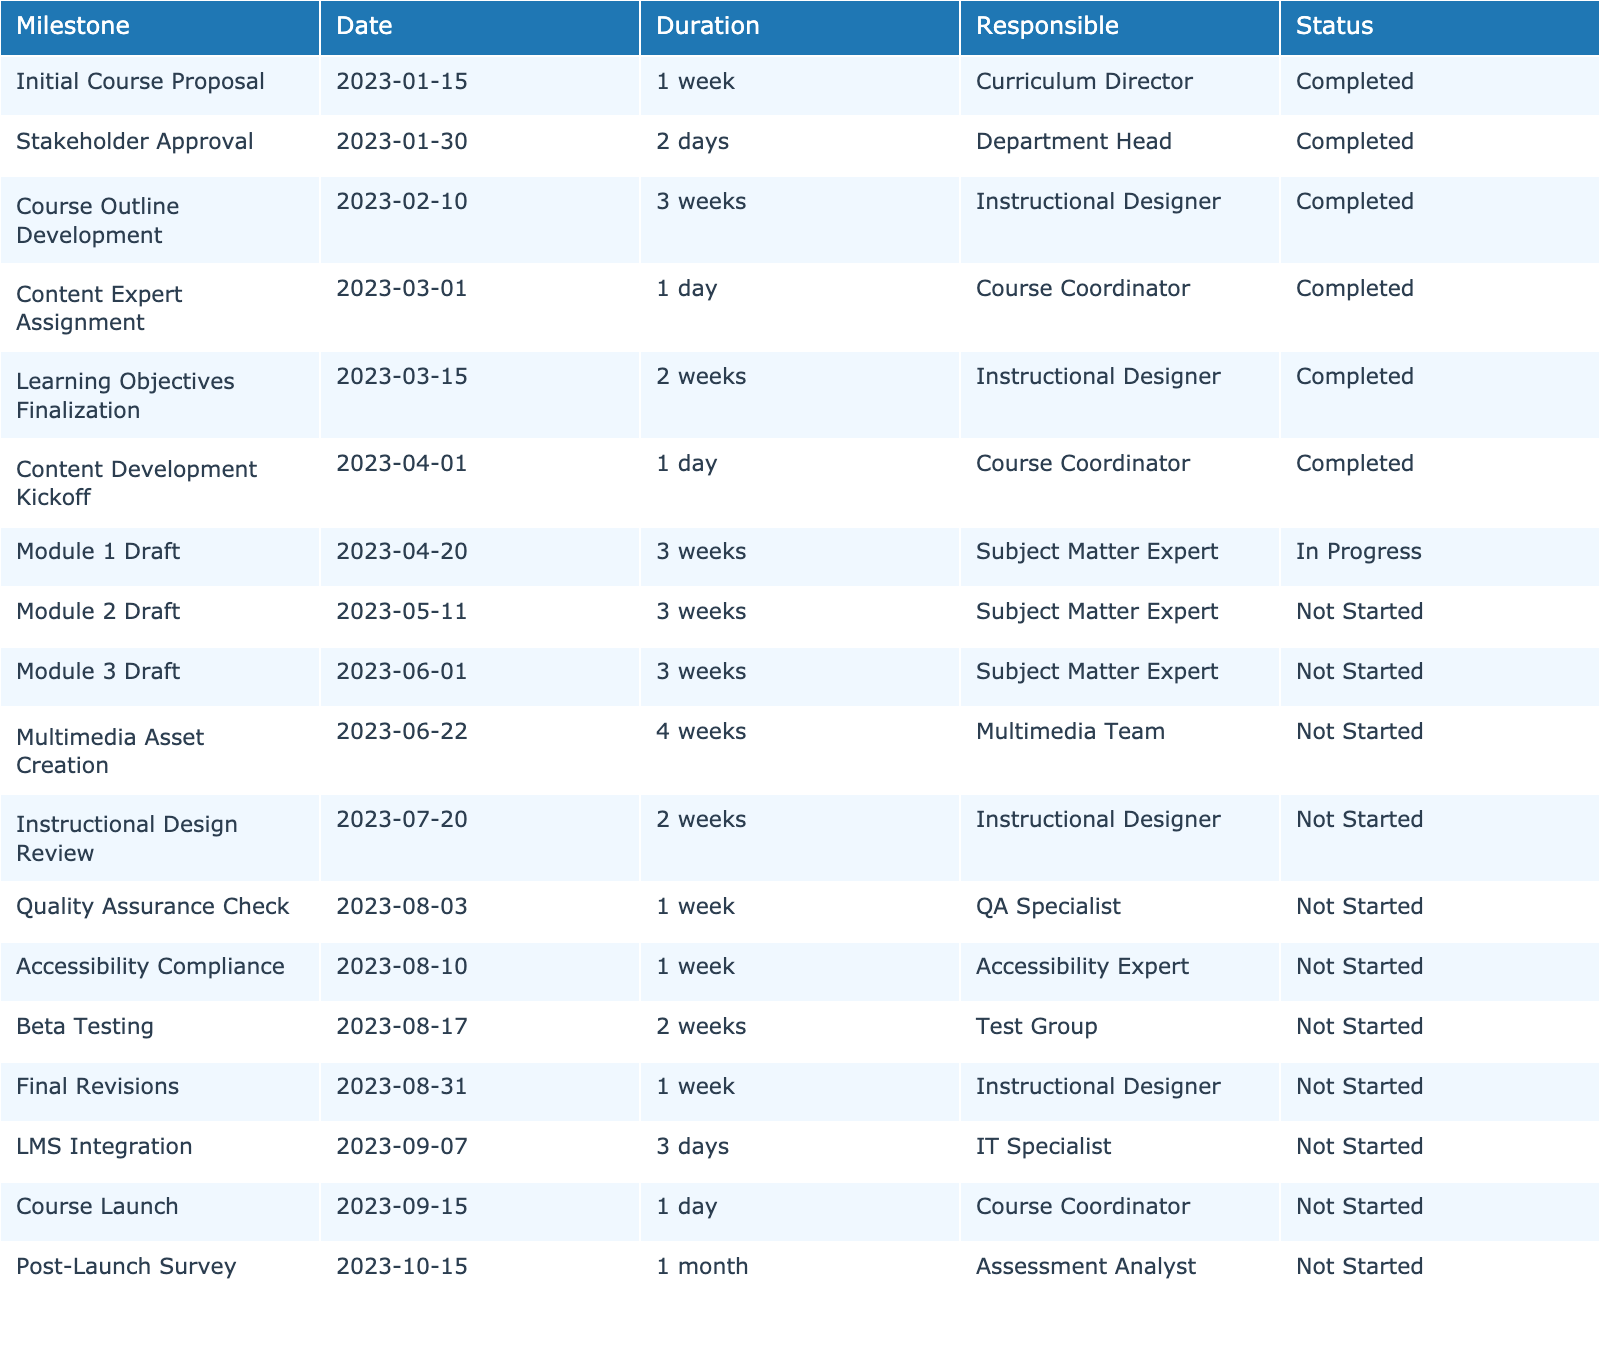What is the status of the "Learning Objectives Finalization" milestone? The table indicates that the status of the "Learning Objectives Finalization" milestone is "Completed."
Answer: Completed How many weeks is allocated for the "Multimedia Asset Creation" phase? The duration for "Multimedia Asset Creation" is 4 weeks according to the table.
Answer: 4 weeks Is there a milestone for "Module 2 Draft"? If so, what is its status? Yes, "Module 2 Draft" is listed in the table, and its status is "Not Started."
Answer: Yes, Not Started What is the date when the "Final Revisions" milestone is scheduled to begin? According to the table, "Final Revisions" is scheduled to begin on August 31, 2023.
Answer: August 31, 2023 How many milestones are marked as "In Progress"? The table shows that there is 1 milestone marked as "In Progress," which is "Module 1 Draft."
Answer: 1 Which milestone has the shortest duration and what is it? The milestone with the shortest duration is "Content Expert Assignment," with a duration of 1 day.
Answer: Content Expert Assignment, 1 day What is the total duration in weeks for all "Not Started" milestones? There are 8 milestones marked as "Not Started." Their durations are 3 weeks (Module 2 Draft) + 3 weeks (Module 3 Draft) + 4 weeks (Multimedia Asset Creation) + 2 weeks (Instructional Design Review) + 1 week (Quality Assurance Check) + 1 week (Accessibility Compliance) + 2 weeks (Beta Testing) + 1 week (Final Revisions) totaling 18 weeks.
Answer: 18 weeks Which team is responsible for "Course Outline Development"? The responsibility for "Course Outline Development" is assigned to the Instructional Designer, as stated in the table.
Answer: Instructional Designer What is the difference in the start date between the "Content Development Kickoff" and "Course Launch"? "Content Development Kickoff" starts on April 1, 2023, and "Course Launch" starts on September 15, 2023. The difference in days is 166 days.
Answer: 166 days Which milestone directly follows "Stakeholder Approval"? The next milestone following "Stakeholder Approval" is "Course Outline Development," starting on February 10, 2023.
Answer: Course Outline Development How many days are allotted for "LMS Integration"? The table shows that "LMS Integration" is allotted 3 days.
Answer: 3 days 